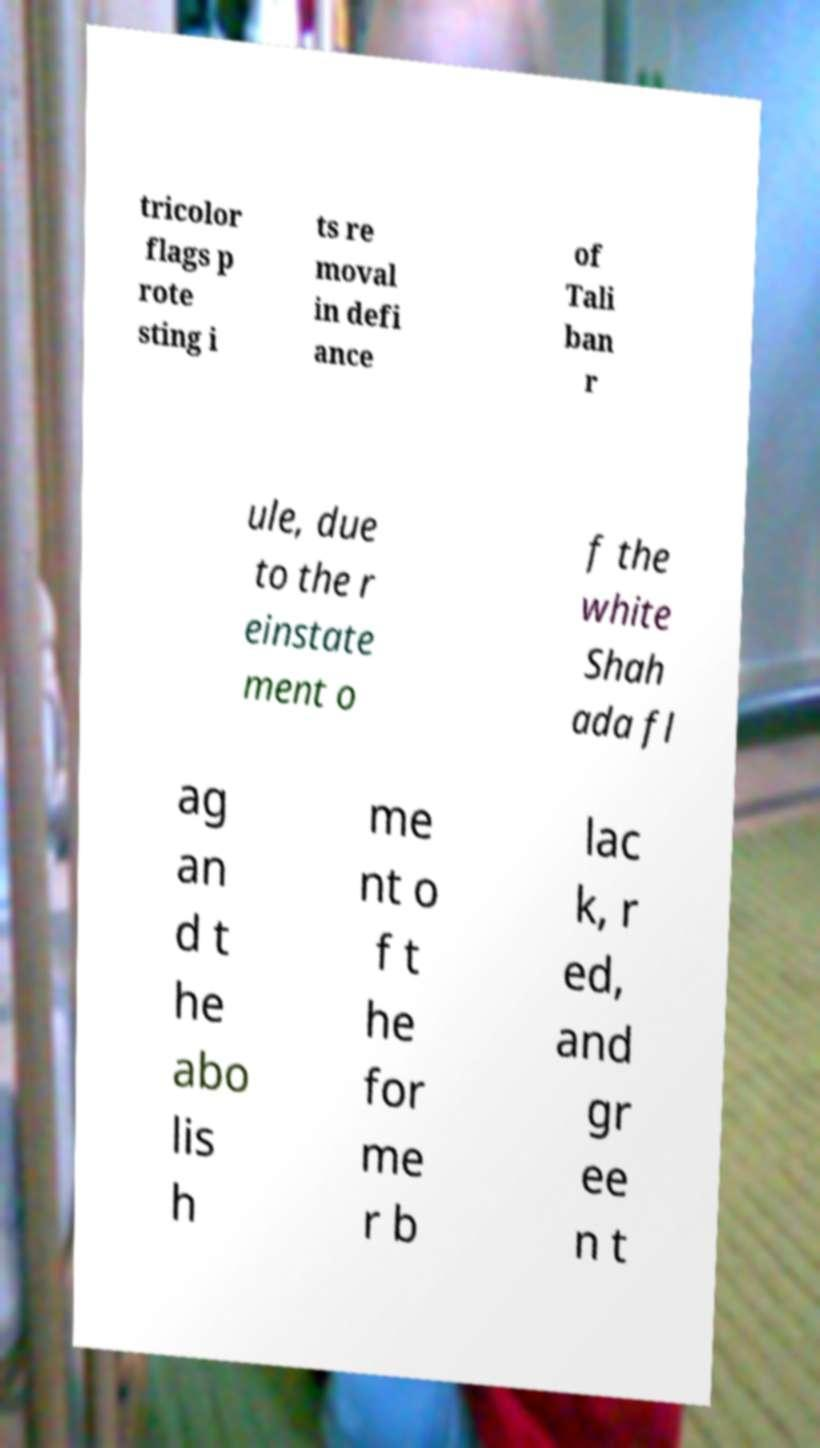There's text embedded in this image that I need extracted. Can you transcribe it verbatim? tricolor flags p rote sting i ts re moval in defi ance of Tali ban r ule, due to the r einstate ment o f the white Shah ada fl ag an d t he abo lis h me nt o f t he for me r b lac k, r ed, and gr ee n t 